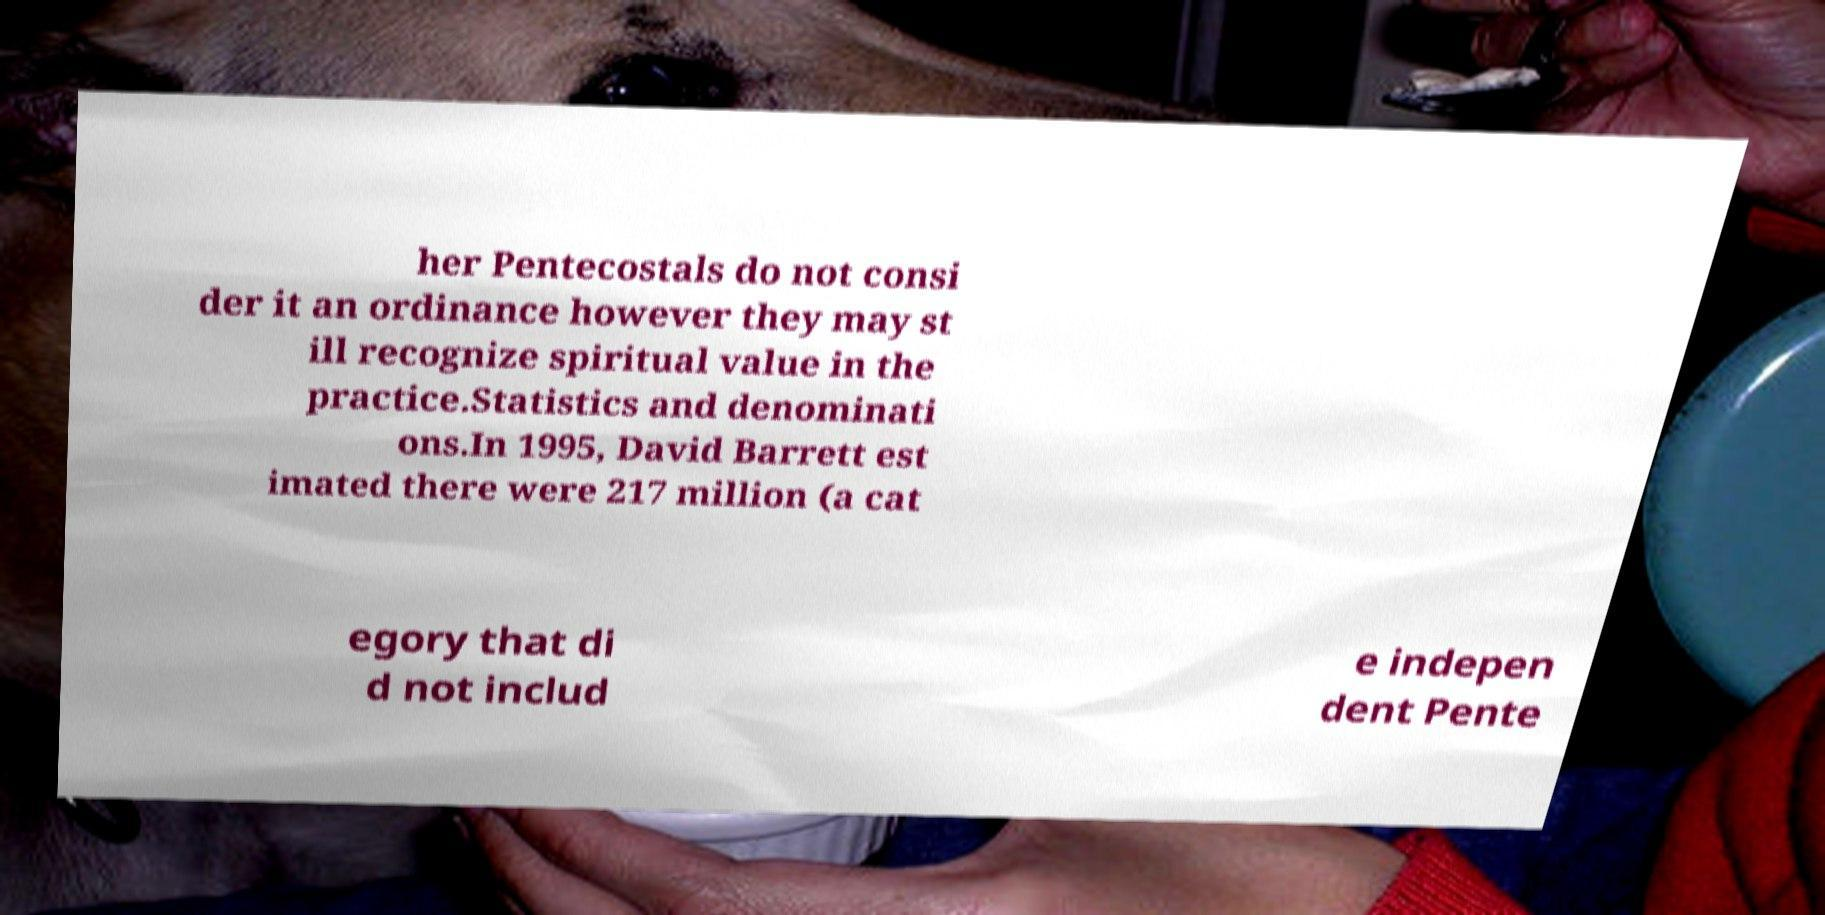Could you assist in decoding the text presented in this image and type it out clearly? her Pentecostals do not consi der it an ordinance however they may st ill recognize spiritual value in the practice.Statistics and denominati ons.In 1995, David Barrett est imated there were 217 million (a cat egory that di d not includ e indepen dent Pente 